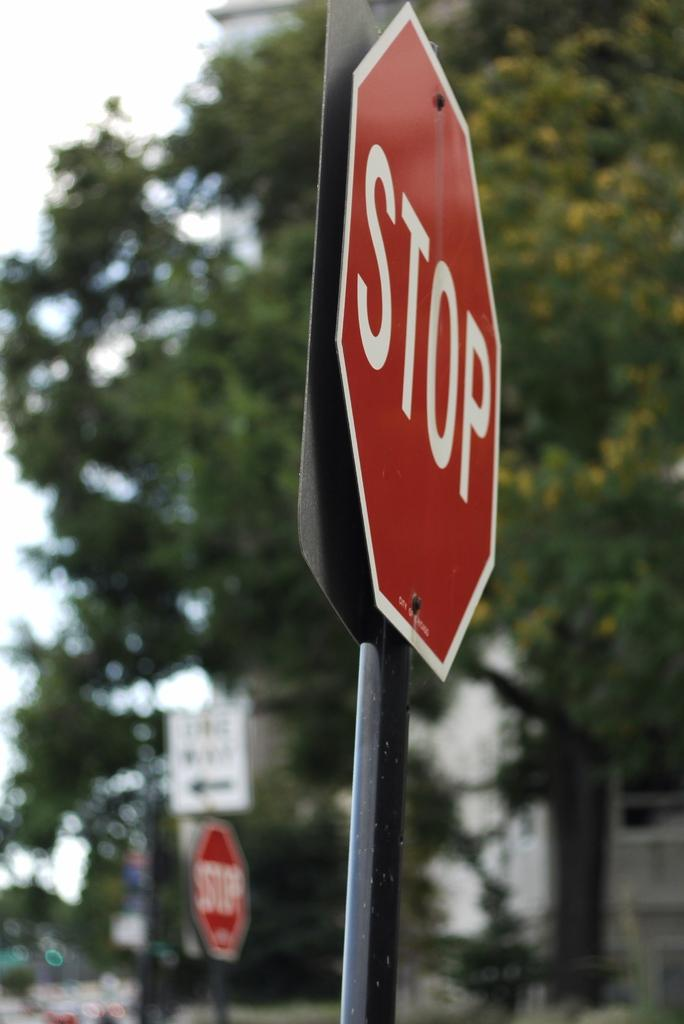<image>
Share a concise interpretation of the image provided. A STOP sign is on the street shown from a side view. 